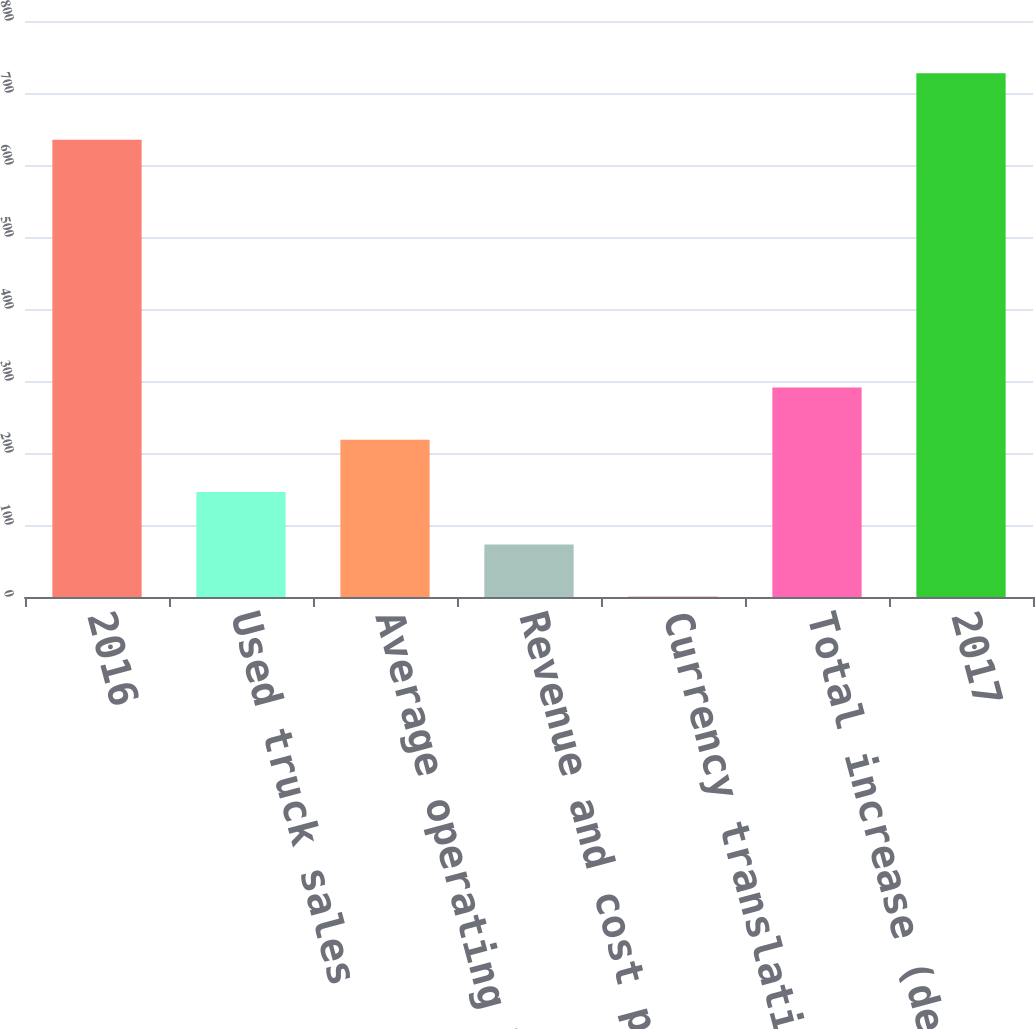<chart> <loc_0><loc_0><loc_500><loc_500><bar_chart><fcel>2016<fcel>Used truck sales<fcel>Average operating lease assets<fcel>Revenue and cost per asset<fcel>Currency translation and other<fcel>Total increase (decrease)<fcel>2017<nl><fcel>635.2<fcel>145.66<fcel>218.39<fcel>72.93<fcel>0.2<fcel>291.12<fcel>727.5<nl></chart> 